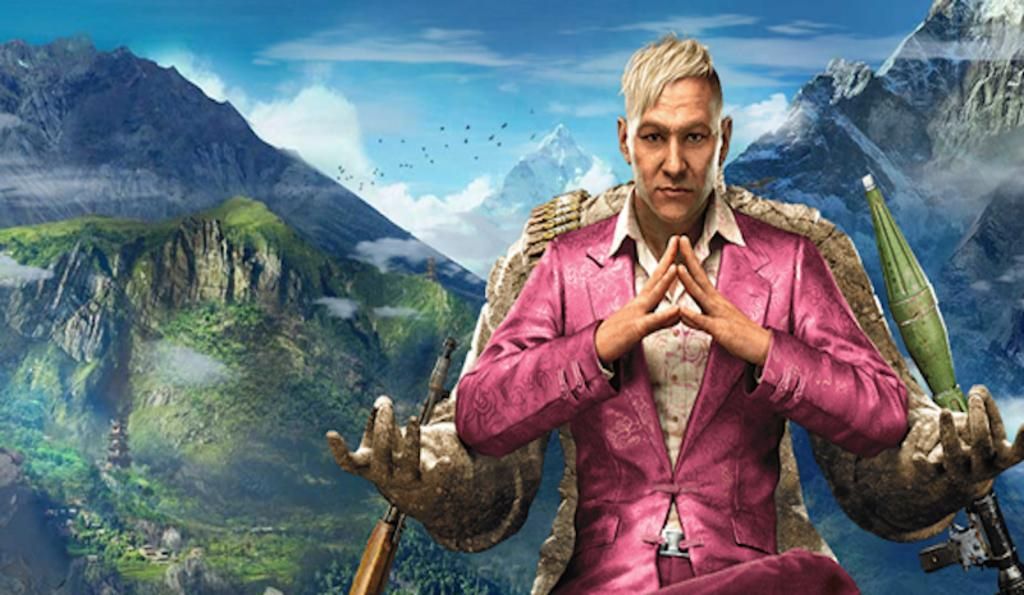What type of image is being described? The image is an animated picture. Who or what can be seen in the image? There is a man in the image. What type of landscape is visible in the image? There are hills in the image. What else can be seen in the sky in the image? There are clouds in the image. Where is the playground located in the image? There is no playground present in the image. What type of dolls can be seen interacting with the man in the image? There are no dolls present in the image. 